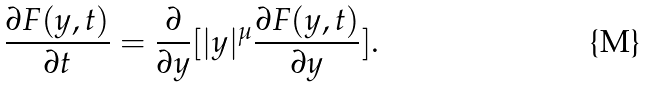Convert formula to latex. <formula><loc_0><loc_0><loc_500><loc_500>\frac { \partial F ( y , t ) } { \partial t } = \frac { \partial } { \partial y } [ | y | ^ { \mu } \frac { \partial F ( y , t ) } { \partial y } ] .</formula> 